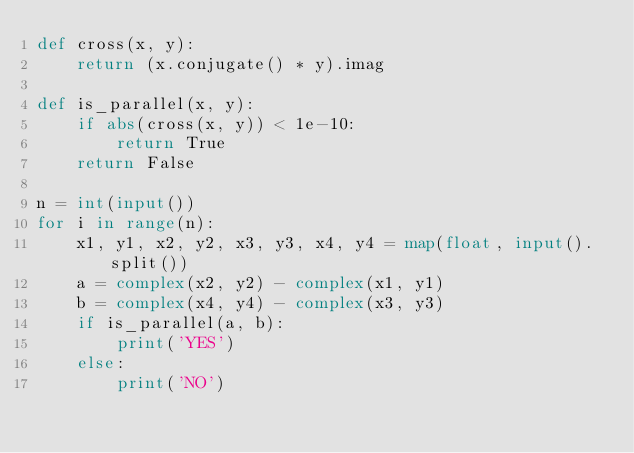Convert code to text. <code><loc_0><loc_0><loc_500><loc_500><_Python_>def cross(x, y):
    return (x.conjugate() * y).imag

def is_parallel(x, y):
    if abs(cross(x, y)) < 1e-10:
        return True
    return False

n = int(input())
for i in range(n):
    x1, y1, x2, y2, x3, y3, x4, y4 = map(float, input().split())
    a = complex(x2, y2) - complex(x1, y1)
    b = complex(x4, y4) - complex(x3, y3)    
    if is_parallel(a, b):
        print('YES')
    else:
        print('NO')</code> 